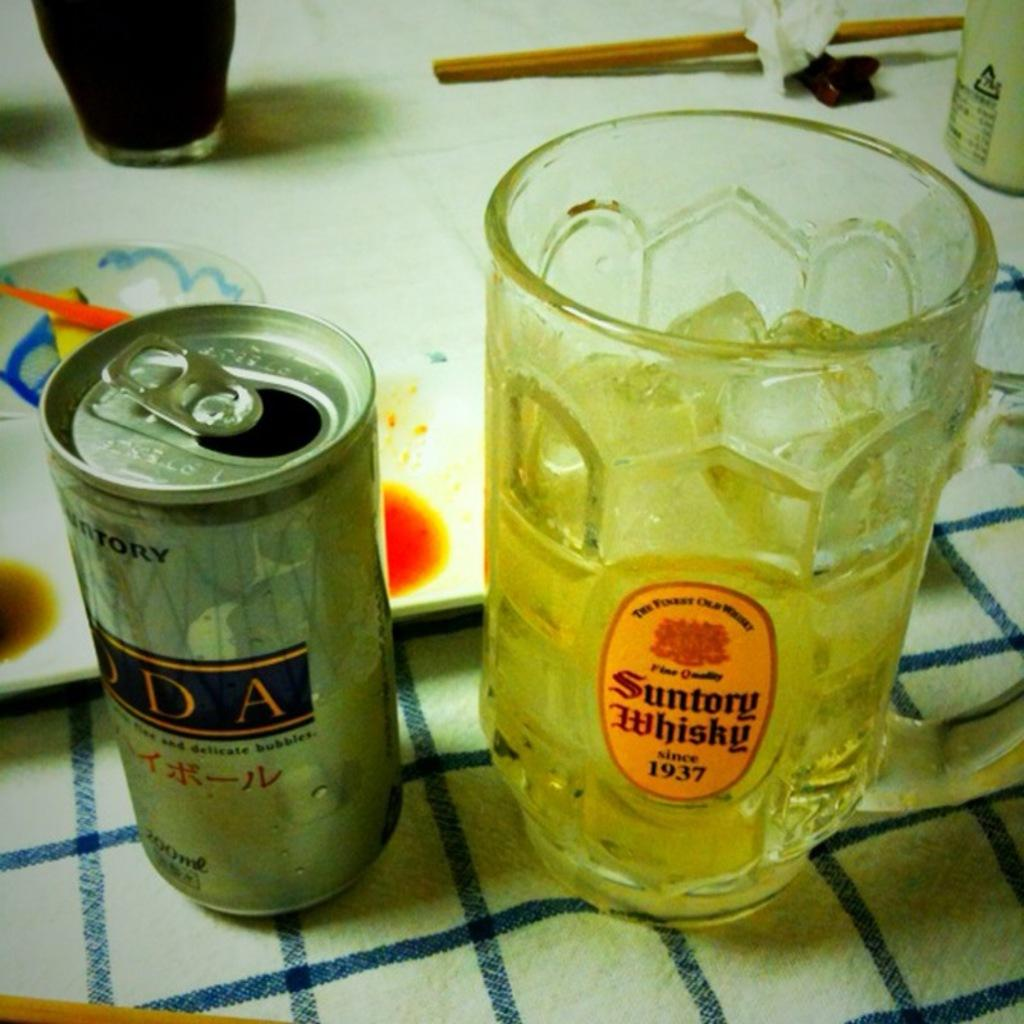Provide a one-sentence caption for the provided image. An open can next to a Suntory Whisky glass with ice and liquid. 